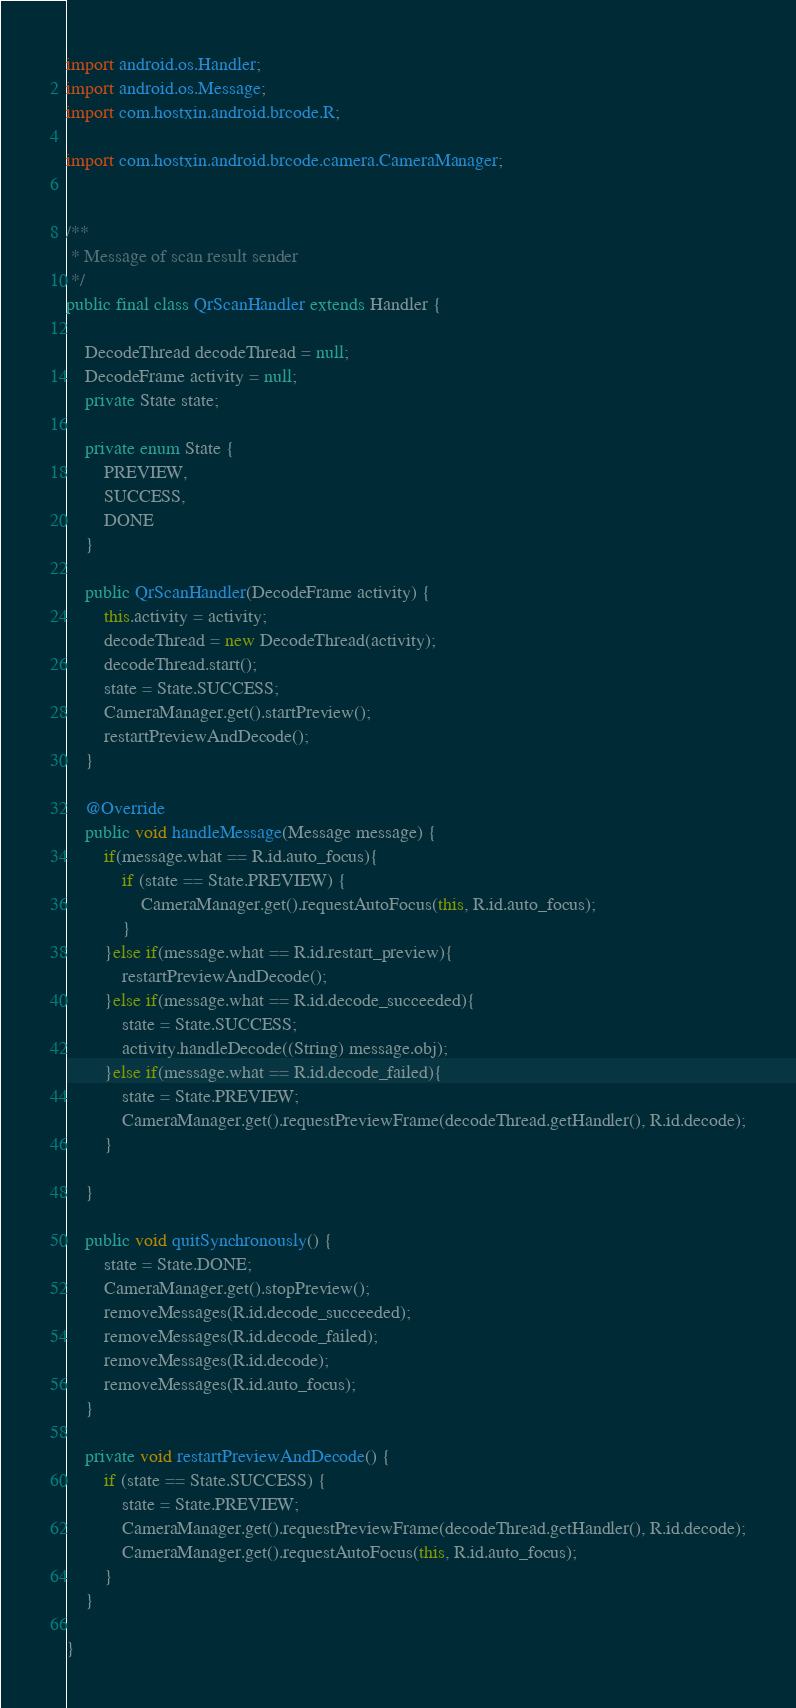<code> <loc_0><loc_0><loc_500><loc_500><_Java_>import android.os.Handler;
import android.os.Message;
import com.hostxin.android.brcode.R;

import com.hostxin.android.brcode.camera.CameraManager;


/**
 * Message of scan result sender
 */
public final class QrScanHandler extends Handler {

    DecodeThread decodeThread = null;
    DecodeFrame activity = null;
    private State state;

    private enum State {
        PREVIEW,
        SUCCESS,
        DONE
    }

    public QrScanHandler(DecodeFrame activity) {
        this.activity = activity;
        decodeThread = new DecodeThread(activity);
        decodeThread.start();
        state = State.SUCCESS;
        CameraManager.get().startPreview();
        restartPreviewAndDecode();
    }

    @Override
    public void handleMessage(Message message) {
        if(message.what == R.id.auto_focus){
            if (state == State.PREVIEW) {
                CameraManager.get().requestAutoFocus(this, R.id.auto_focus);
            }
        }else if(message.what == R.id.restart_preview){
            restartPreviewAndDecode();
        }else if(message.what == R.id.decode_succeeded){
            state = State.SUCCESS;
            activity.handleDecode((String) message.obj);
        }else if(message.what == R.id.decode_failed){
            state = State.PREVIEW;
            CameraManager.get().requestPreviewFrame(decodeThread.getHandler(), R.id.decode);
        }

    }

    public void quitSynchronously() {
        state = State.DONE;
        CameraManager.get().stopPreview();
        removeMessages(R.id.decode_succeeded);
        removeMessages(R.id.decode_failed);
        removeMessages(R.id.decode);
        removeMessages(R.id.auto_focus);
    }

    private void restartPreviewAndDecode() {
        if (state == State.SUCCESS) {
            state = State.PREVIEW;
            CameraManager.get().requestPreviewFrame(decodeThread.getHandler(), R.id.decode);
            CameraManager.get().requestAutoFocus(this, R.id.auto_focus);
        }
    }

}
</code> 